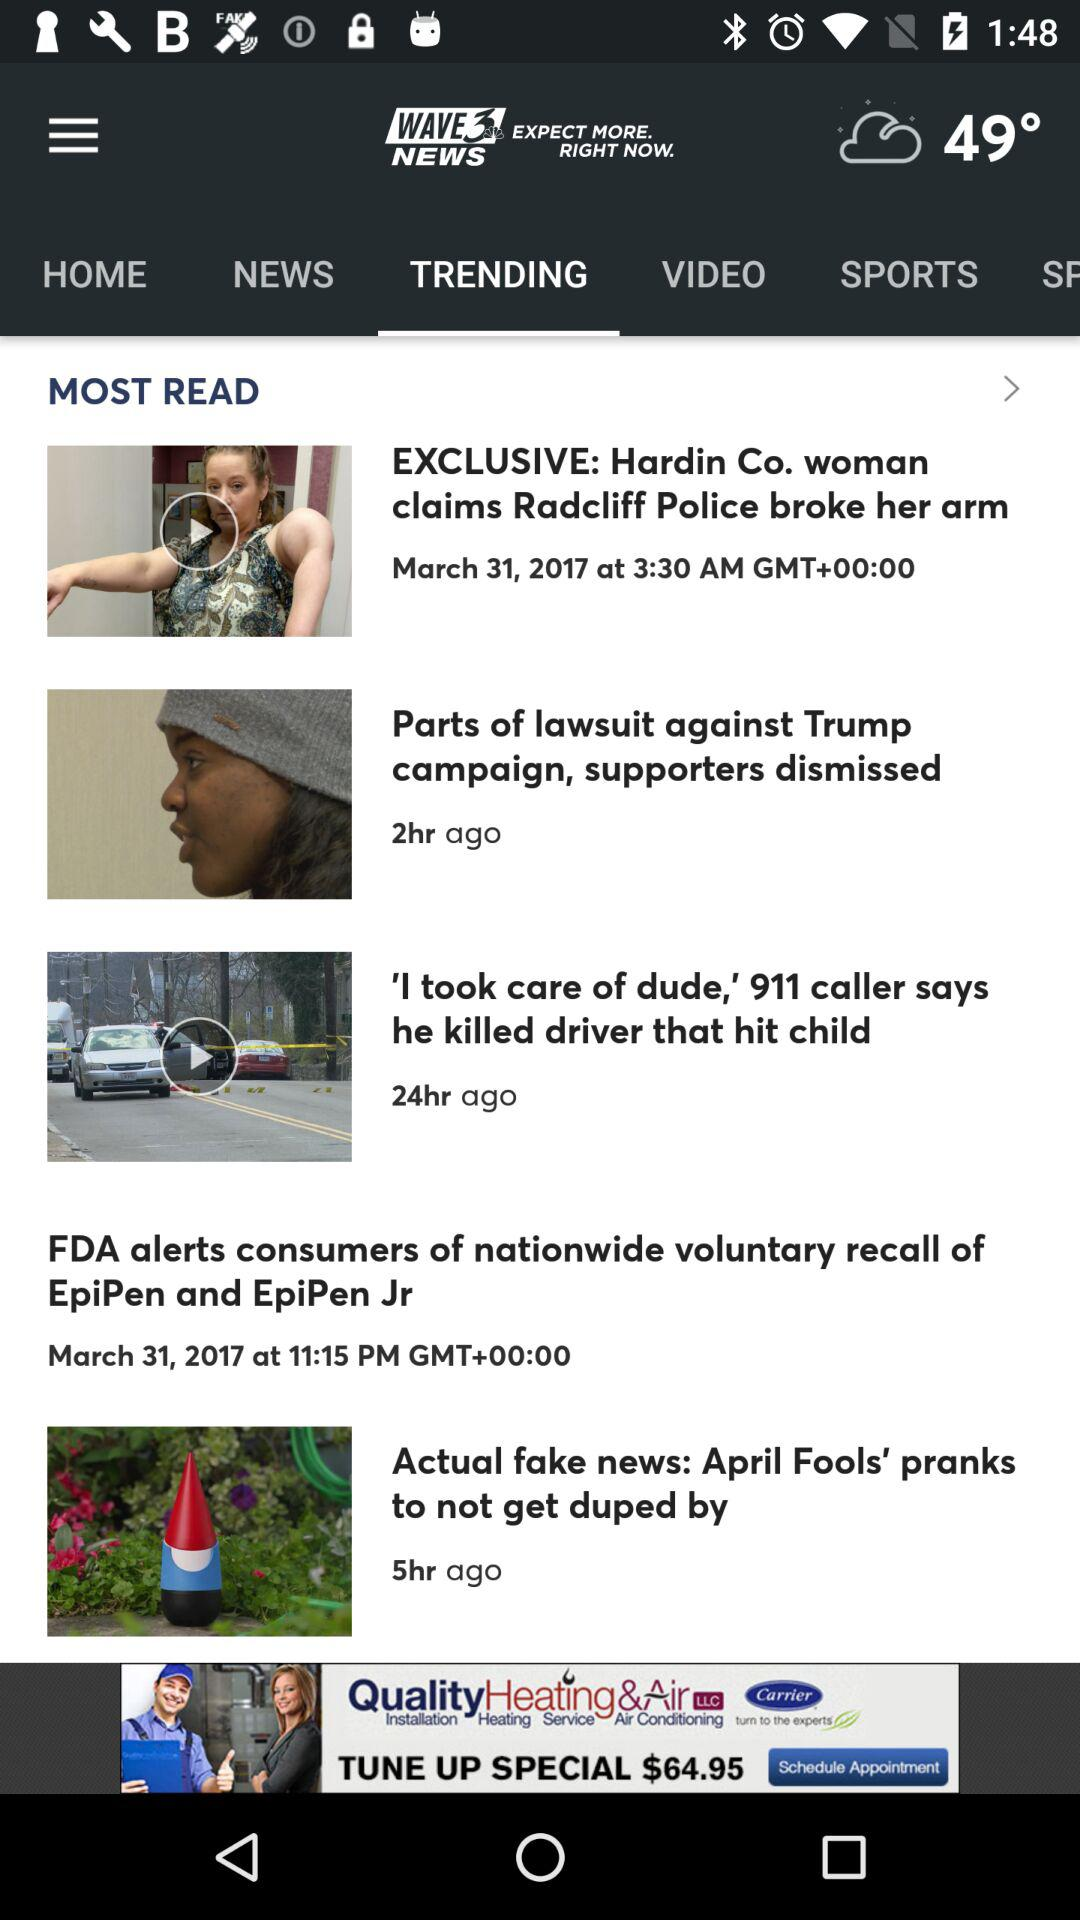What is the date of the video titled "Hardin Co. woman claims Radcliff Police broke her arm"? The date of the video titled "Hardin Co. woman claims Radcliff Police broke her arm" is March 31, 2017. 